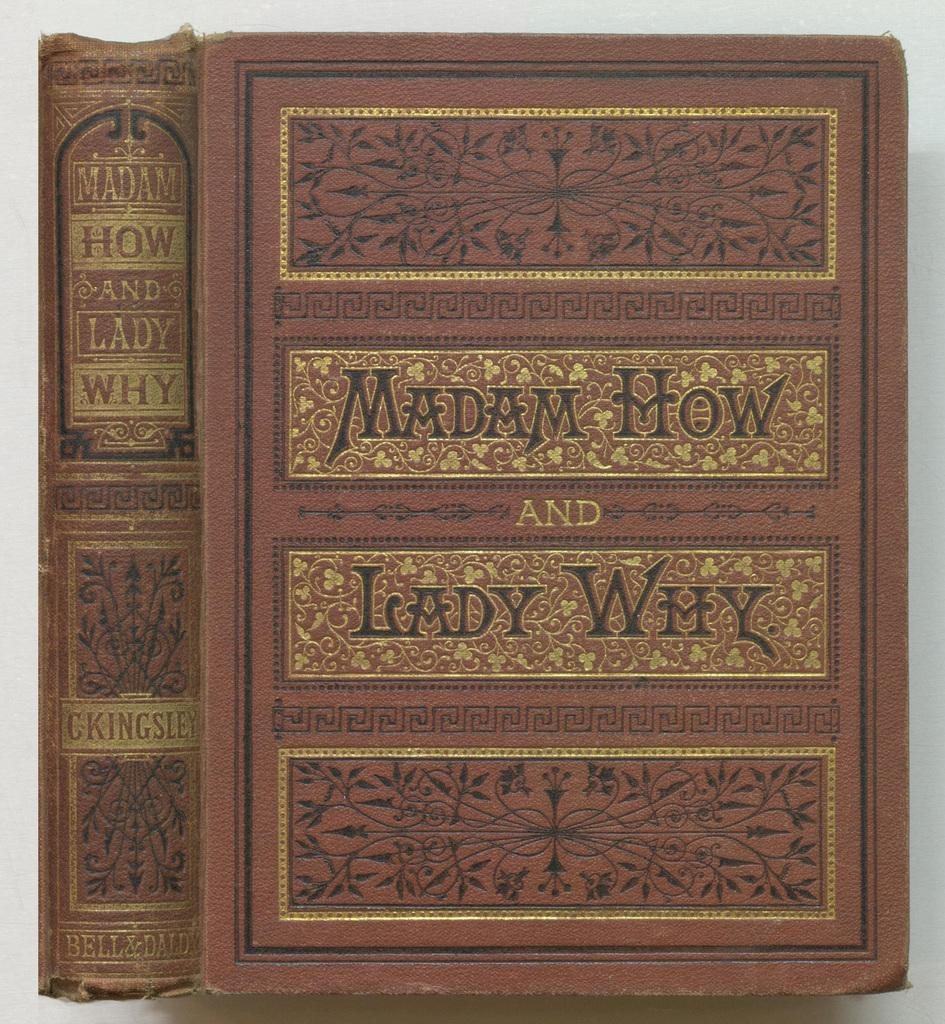<image>
Summarize the visual content of the image. Two edition of the book of Madam How and Lady Why standing upright next to each other. 